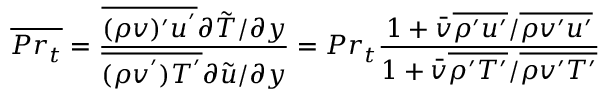<formula> <loc_0><loc_0><loc_500><loc_500>\overline { { P r _ { t } } } = \frac { \overline { { ( \rho v ) ^ { \prime } u ^ { ^ { \prime } } } } \partial \tilde { T } / \partial y } { \overline { { ( \rho v ^ { ^ { \prime } } ) T ^ { ^ { \prime } } } } \partial \tilde { u } / \partial y } = P r _ { t } \frac { 1 + \bar { v } \overline { { \rho ^ { \prime } u ^ { \prime } } } / \overline { { \rho v ^ { \prime } u ^ { \prime } } } } { 1 + \bar { v } \overline { { \rho ^ { \prime } T ^ { \prime } } } / \overline { { \rho v ^ { \prime } T ^ { \prime } } } }</formula> 